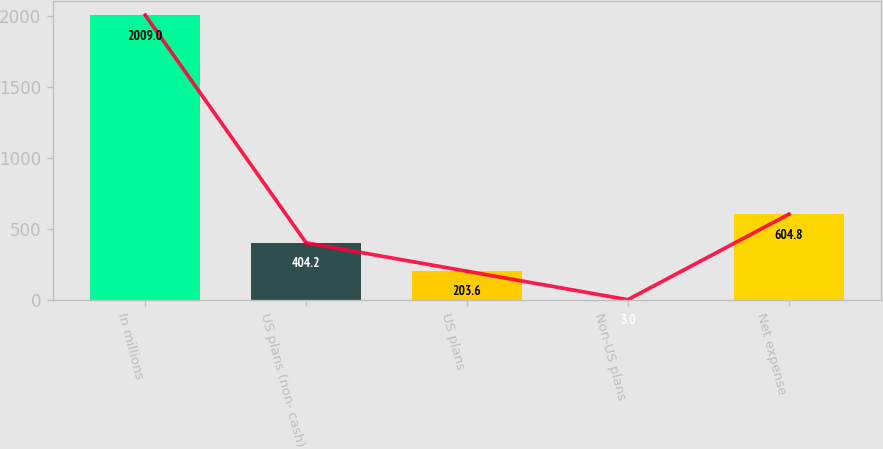Convert chart to OTSL. <chart><loc_0><loc_0><loc_500><loc_500><bar_chart><fcel>In millions<fcel>US plans (non- cash)<fcel>US plans<fcel>Non-US plans<fcel>Net expense<nl><fcel>2009<fcel>404.2<fcel>203.6<fcel>3<fcel>604.8<nl></chart> 